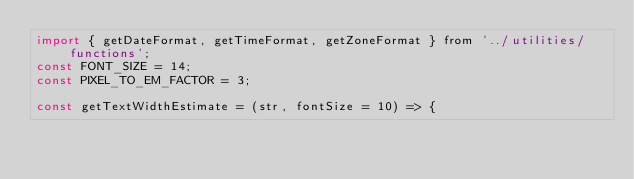<code> <loc_0><loc_0><loc_500><loc_500><_JavaScript_>import { getDateFormat, getTimeFormat, getZoneFormat } from '../utilities/functions';
const FONT_SIZE = 14;
const PIXEL_TO_EM_FACTOR = 3;

const getTextWidthEstimate = (str, fontSize = 10) => {</code> 